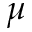<formula> <loc_0><loc_0><loc_500><loc_500>\mu</formula> 